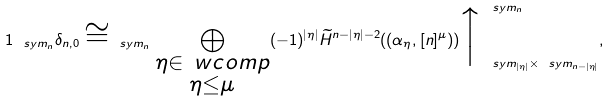<formula> <loc_0><loc_0><loc_500><loc_500>1 _ { \ s y m _ { n } } \delta _ { n , 0 } \cong _ { \ s y m _ { n } } \bigoplus _ { \substack { \eta \in \ w c o m p \\ \eta \leq \mu } } ( - 1 ) ^ { | \eta | } \widetilde { H } ^ { n - | \eta | - 2 } ( ( \alpha _ { \eta } , [ n ] ^ { \mu } ) ) \Big \uparrow _ { \ s y m _ { | \eta | } \times \ s y m _ { n - | \eta | } } ^ { \ s y m _ { n } } ,</formula> 